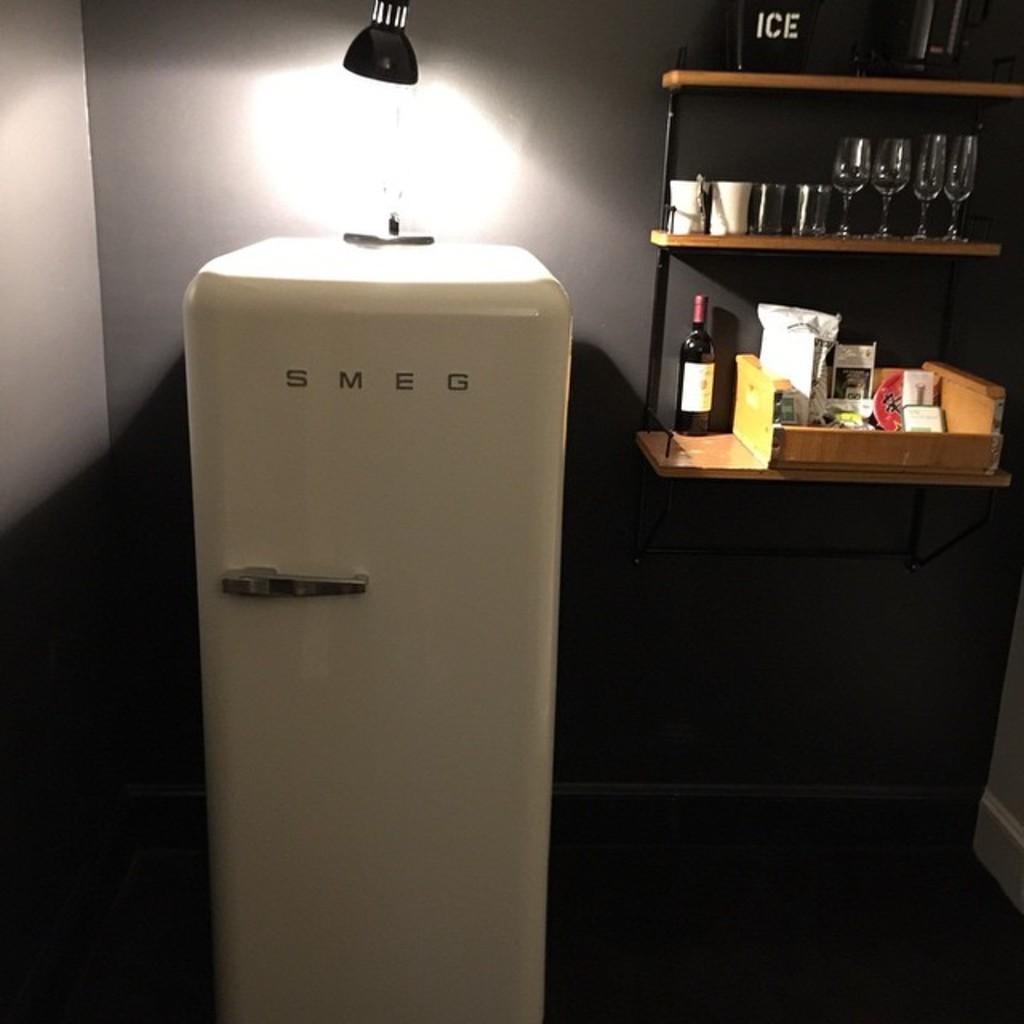What is the black bucket for on the shelf?
Offer a very short reply. Ice. What is the name of the big white box?
Provide a succinct answer. Smeg. 